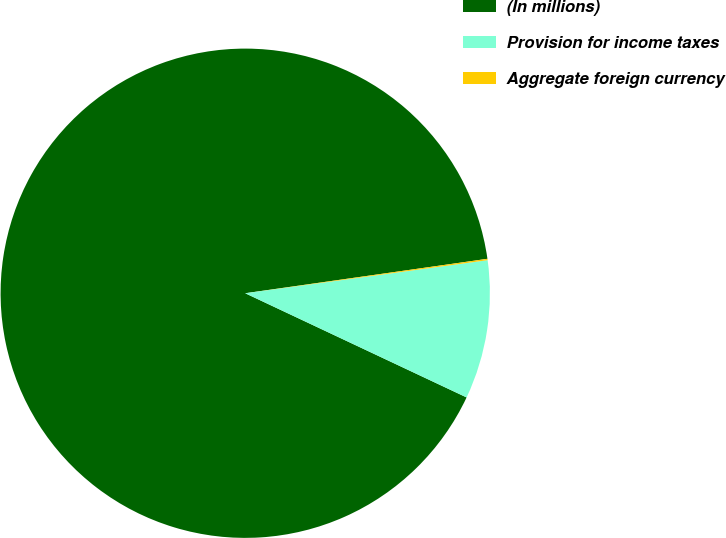<chart> <loc_0><loc_0><loc_500><loc_500><pie_chart><fcel>(In millions)<fcel>Provision for income taxes<fcel>Aggregate foreign currency<nl><fcel>90.75%<fcel>9.16%<fcel>0.09%<nl></chart> 